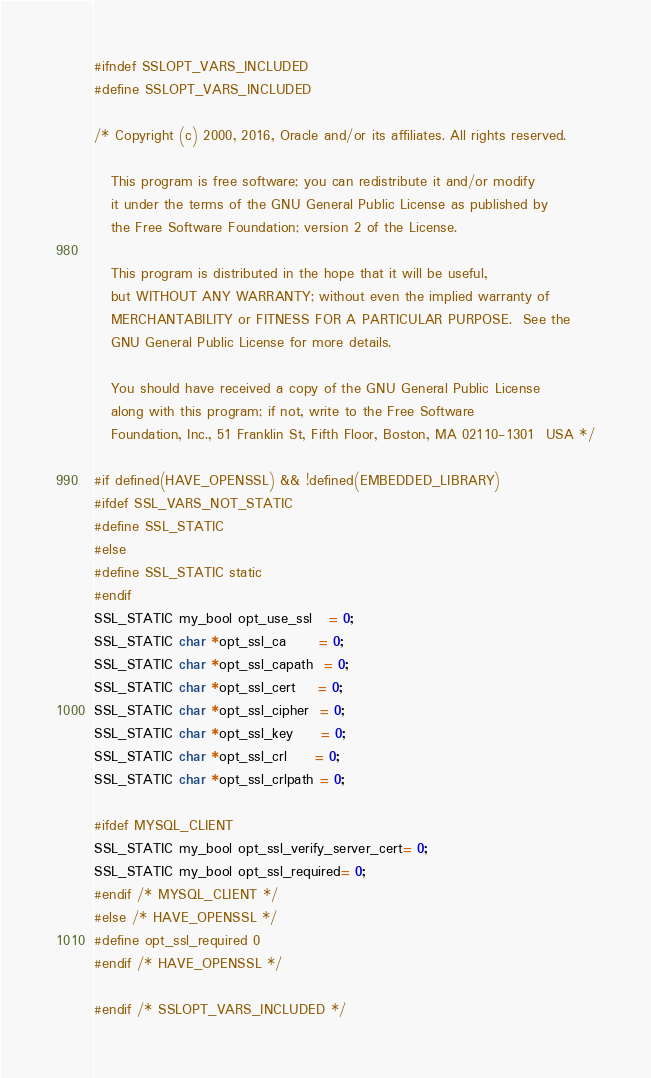<code> <loc_0><loc_0><loc_500><loc_500><_C_>#ifndef SSLOPT_VARS_INCLUDED
#define SSLOPT_VARS_INCLUDED

/* Copyright (c) 2000, 2016, Oracle and/or its affiliates. All rights reserved.

   This program is free software; you can redistribute it and/or modify
   it under the terms of the GNU General Public License as published by
   the Free Software Foundation; version 2 of the License.

   This program is distributed in the hope that it will be useful,
   but WITHOUT ANY WARRANTY; without even the implied warranty of
   MERCHANTABILITY or FITNESS FOR A PARTICULAR PURPOSE.  See the
   GNU General Public License for more details.

   You should have received a copy of the GNU General Public License
   along with this program; if not, write to the Free Software
   Foundation, Inc., 51 Franklin St, Fifth Floor, Boston, MA 02110-1301  USA */

#if defined(HAVE_OPENSSL) && !defined(EMBEDDED_LIBRARY)
#ifdef SSL_VARS_NOT_STATIC
#define SSL_STATIC
#else
#define SSL_STATIC static
#endif
SSL_STATIC my_bool opt_use_ssl   = 0;
SSL_STATIC char *opt_ssl_ca      = 0;
SSL_STATIC char *opt_ssl_capath  = 0;
SSL_STATIC char *opt_ssl_cert    = 0;
SSL_STATIC char *opt_ssl_cipher  = 0;
SSL_STATIC char *opt_ssl_key     = 0;
SSL_STATIC char *opt_ssl_crl     = 0;
SSL_STATIC char *opt_ssl_crlpath = 0;

#ifdef MYSQL_CLIENT
SSL_STATIC my_bool opt_ssl_verify_server_cert= 0;
SSL_STATIC my_bool opt_ssl_required= 0;
#endif /* MYSQL_CLIENT */
#else /* HAVE_OPENSSL */
#define opt_ssl_required 0
#endif /* HAVE_OPENSSL */

#endif /* SSLOPT_VARS_INCLUDED */
</code> 